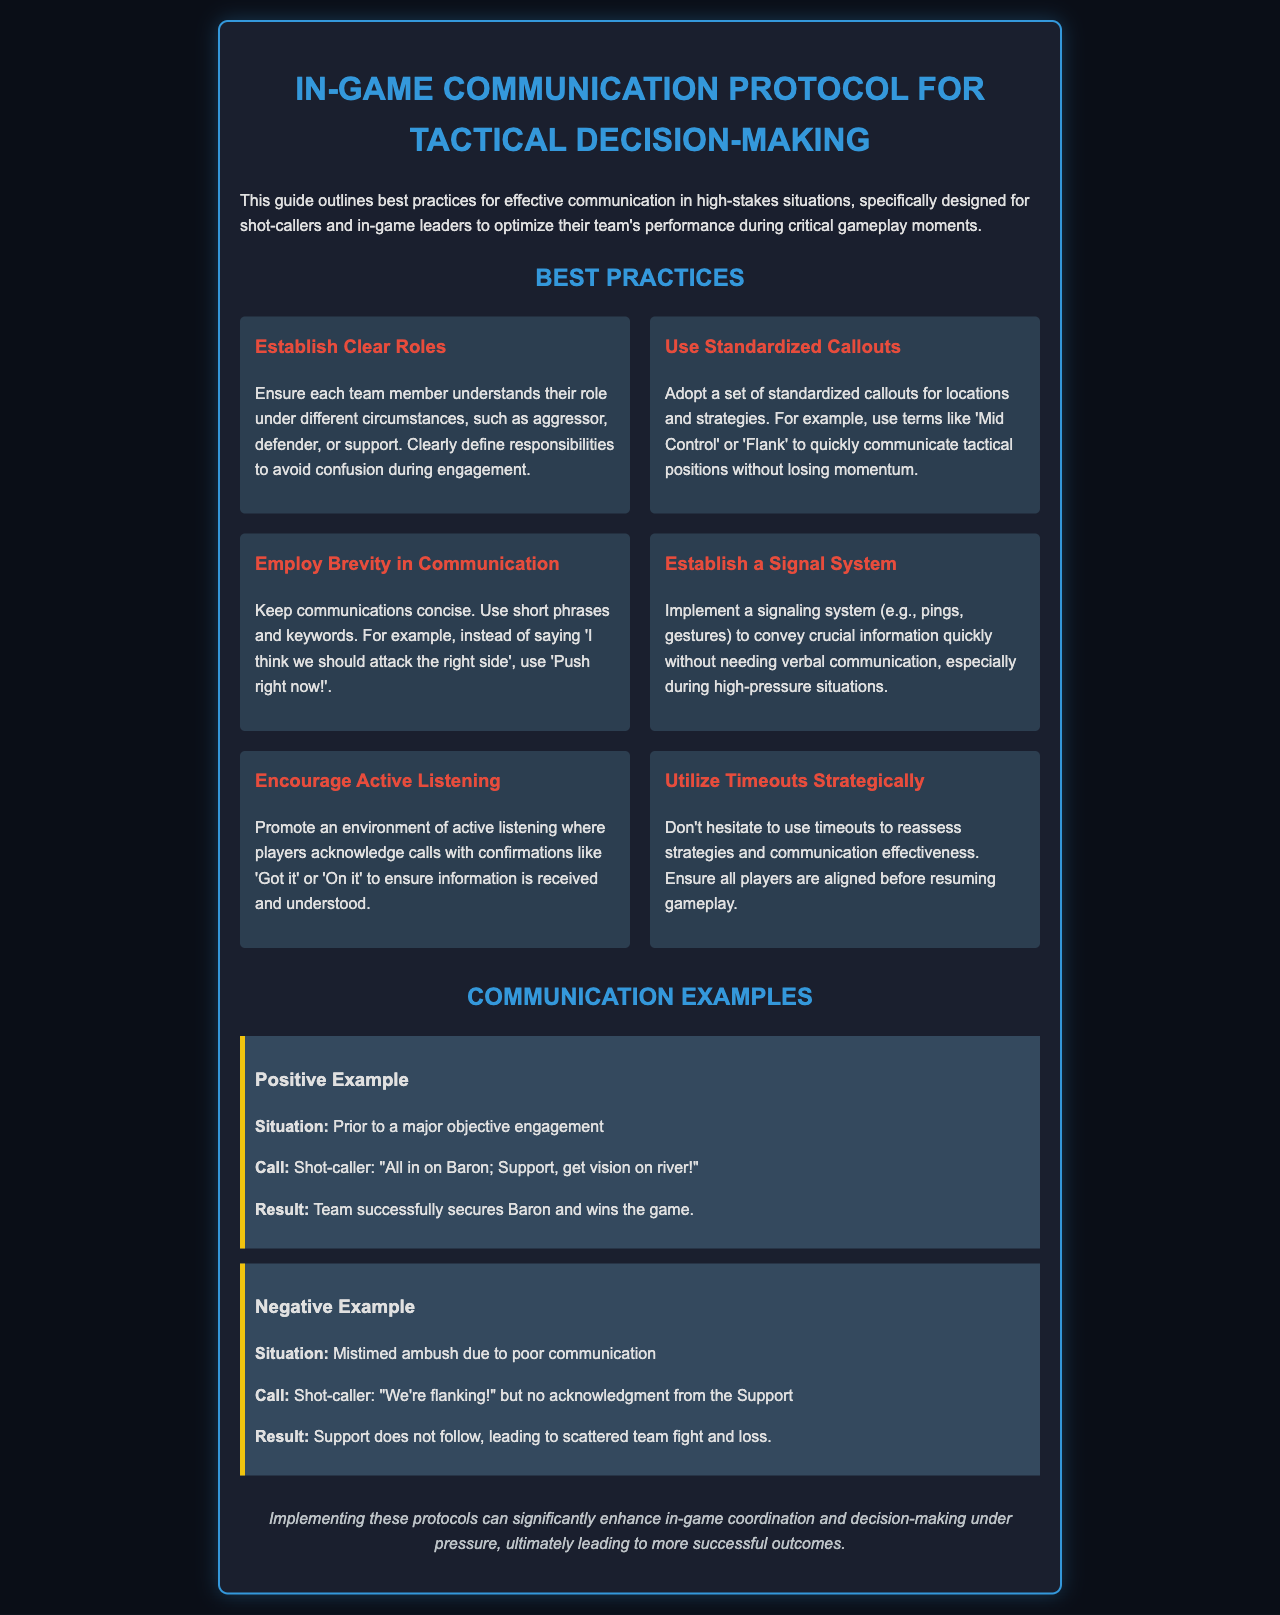What is the title of the document? The title of the document is presented in the header section and clearly states the focus on communication protocols.
Answer: In-Game Communication Protocol for Tactical Decision-Making How many best practices are listed? The number of best practices can be counted from the section that lists them clearly, and there are six practices provided.
Answer: 6 What is one example of a standardized callout? The document provides an example of standardized callouts that can improve communication; one is specifically mentioned.
Answer: Mid Control What is the recommended term for concise communication instead of lengthy sentences? The document emphasizes brevity in communication and suggests a phrase to illustrate this best practice.
Answer: Push right now! What situation does the positive example describe? The positive example highlights a specific situation leading up to an important gameplay moment detailed in the document.
Answer: Prior to a major objective engagement What is the purpose of using timeouts according to the document? The document explains the strategic use of timeouts, which plays a critical role in communication settings.
Answer: Reassess strategies and communication effectiveness What confirms that players have received a call during active listening? The document suggests specific phrases that can indicate acknowledgment within a team, demonstrating effective communication.
Answer: Got it What color is used for the background of the document? The color scheme is described in the styling section of the document to give it an appealing aesthetic.
Answer: Dark blue (or #0a0e17) 